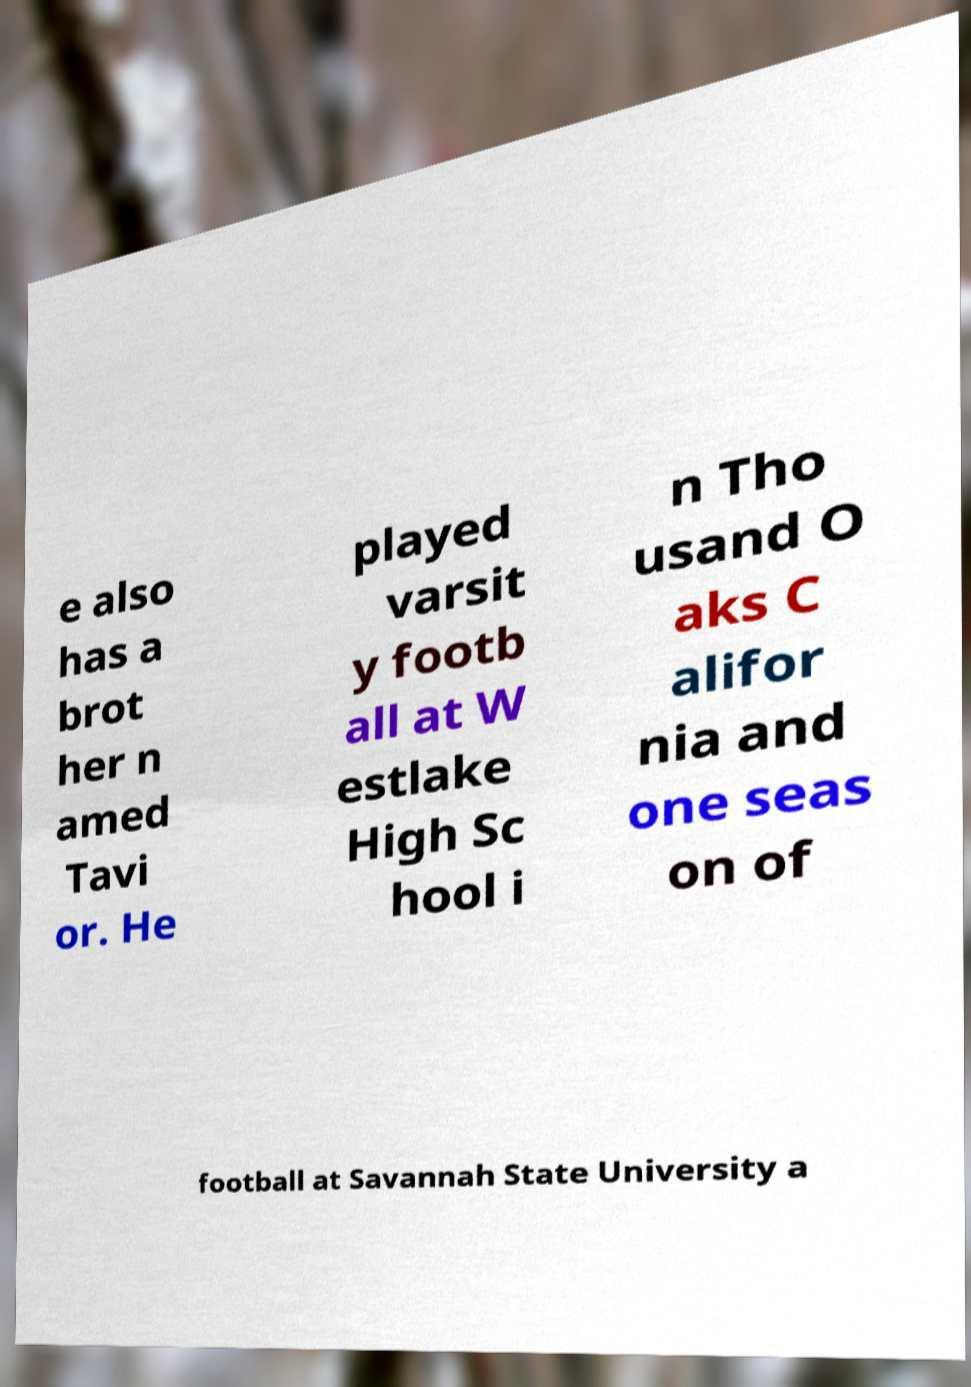What messages or text are displayed in this image? I need them in a readable, typed format. e also has a brot her n amed Tavi or. He played varsit y footb all at W estlake High Sc hool i n Tho usand O aks C alifor nia and one seas on of football at Savannah State University a 